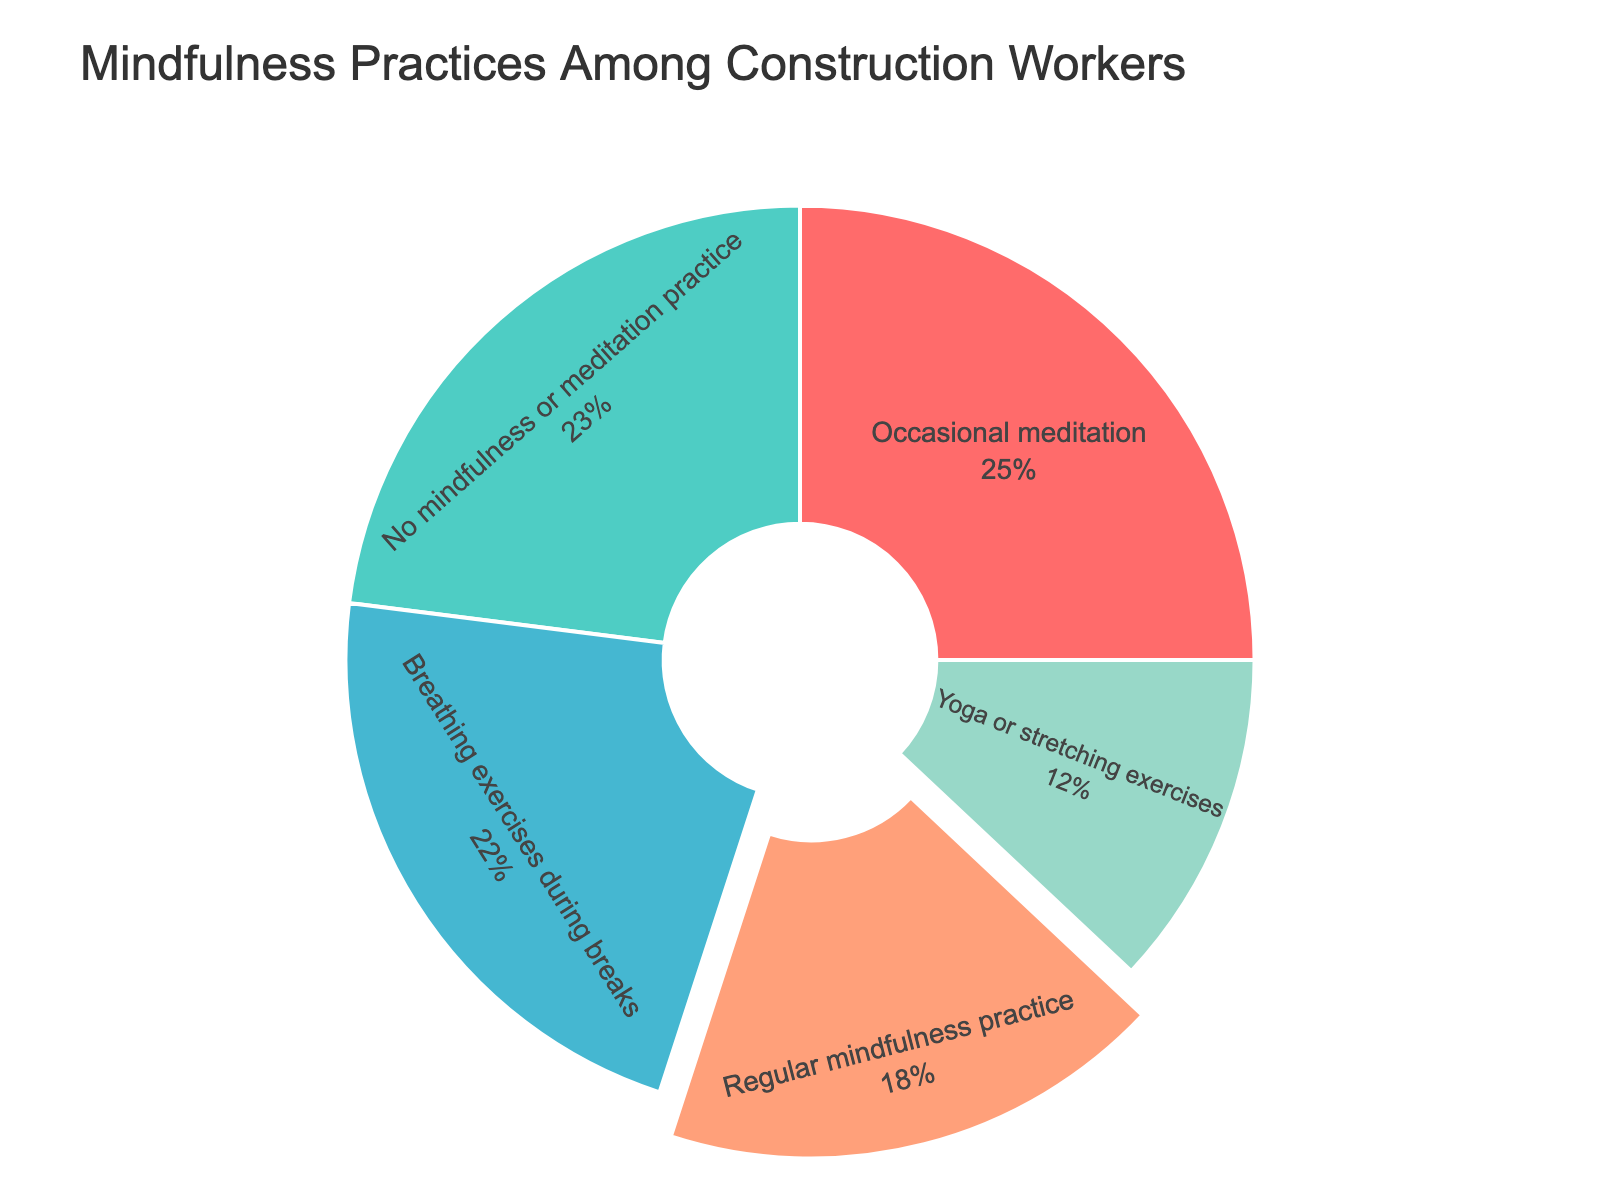**Question Explanation
Answer: Concise Answer** Which mindfulness practice is the most common among construction workers? The largest segment in the pie chart represents the practice with the highest percentage. Identify the practice with the greatest portion.
Answer: Occasional meditation How much larger is the percentage of workers who practice occasional meditation compared to those who do regular mindfulness practice? Subtract the percentage of regular mindfulness practice from the percentage of occasional meditation (25% - 18% = 7%).
Answer: 7% What is the combined percentage of workers who engage in any form of mindfulness or meditation practice (including all practices except those with no practice)? Add the percentages of all mindfulness practices: 18% + 25% + 12% + 22% = 77%.
Answer: 77% Which practice has the smallest percentage of workers engaging in it? Identify the smallest segment in the pie chart. The smallest portion represents the practice with the lowest percentage.
Answer: Yoga or stretching exercises Are there more workers who practice breathing exercises during breaks or those who do regular mindfulness practice? Compare the percentages: Breathing exercises during breaks is 22% and regular mindfulness practice is 18%.
Answer: Breathing exercises during breaks What percentage of workers do not practice any form of mindfulness or meditation? Look for the segment in the pie chart labeled as "No mindfulness or meditation practice.”
Answer: 23% What is the difference in percentage between workers practicing yoga or stretching exercises and those who do breathing exercises during breaks? Subtract the percentage of yoga or stretching exercises from the percentage of breathing exercises during breaks (22% - 12% = 10%).
Answer: 10% Which two practices combined have an equal or almost equal percentage to those who practice no mindfulness or meditation? Add the percentages of different practices and compare with 23%. For example, combining regular mindfulness practice (18%) with yoga or stretching exercises (12%) gives 18% + 12% = 30%, which is close to the 23% who practice no mindfulness.
Answer: Regular mindfulness practice and yoga/stretching exercises What proportion of the pie chart represents mindfulness practices (excluding those with no practice)? Look at the entire pie chart and those slices that are not labeled as "No mindfulness or meditation practice" together make up the proportion. This proportion is the sum of the other percentages (77%). Therefore, this visually corresponds to all the segments excluding the one labeled "No mindfulness or meditation practice."
Answer: 77% Compare the portion sizes of regular mindfulness practice and yoga or stretching exercises. Which one is larger and by how much? Compare the segments: Regular mindfulness practice is 18% and yoga or stretching exercises is 12%. Subtract 12% from 18% to find the difference.
Answer: Regular mindfulness practice by 6% 